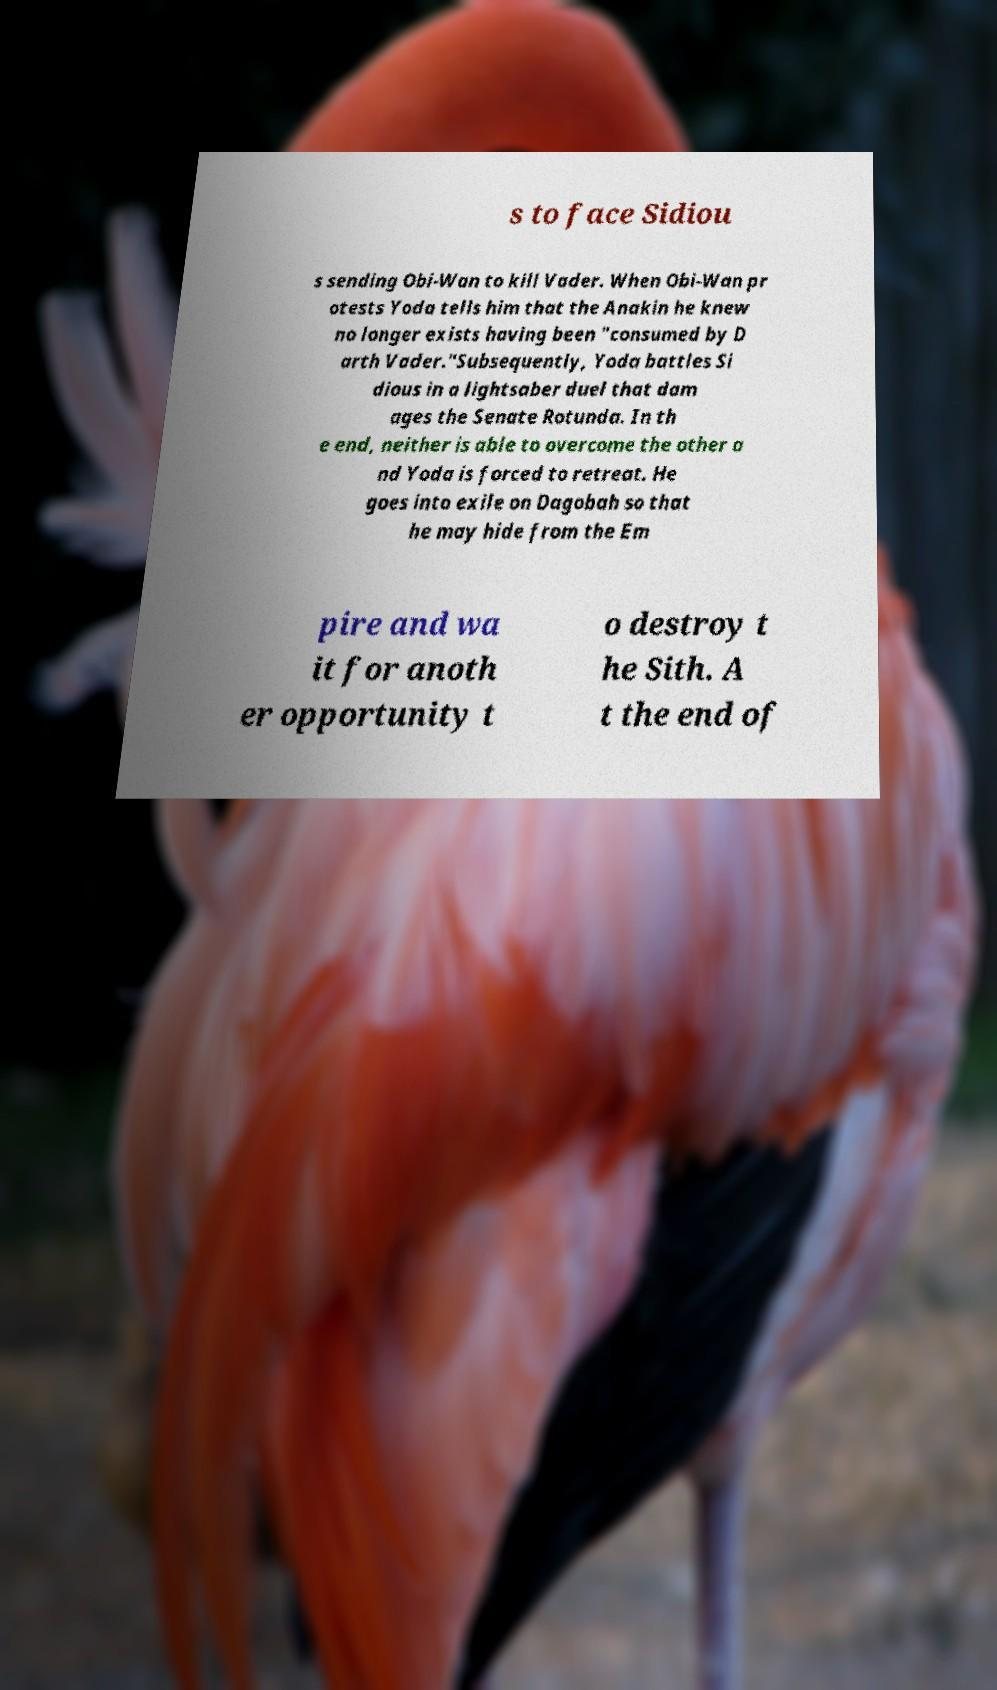Can you accurately transcribe the text from the provided image for me? s to face Sidiou s sending Obi-Wan to kill Vader. When Obi-Wan pr otests Yoda tells him that the Anakin he knew no longer exists having been "consumed by D arth Vader."Subsequently, Yoda battles Si dious in a lightsaber duel that dam ages the Senate Rotunda. In th e end, neither is able to overcome the other a nd Yoda is forced to retreat. He goes into exile on Dagobah so that he may hide from the Em pire and wa it for anoth er opportunity t o destroy t he Sith. A t the end of 